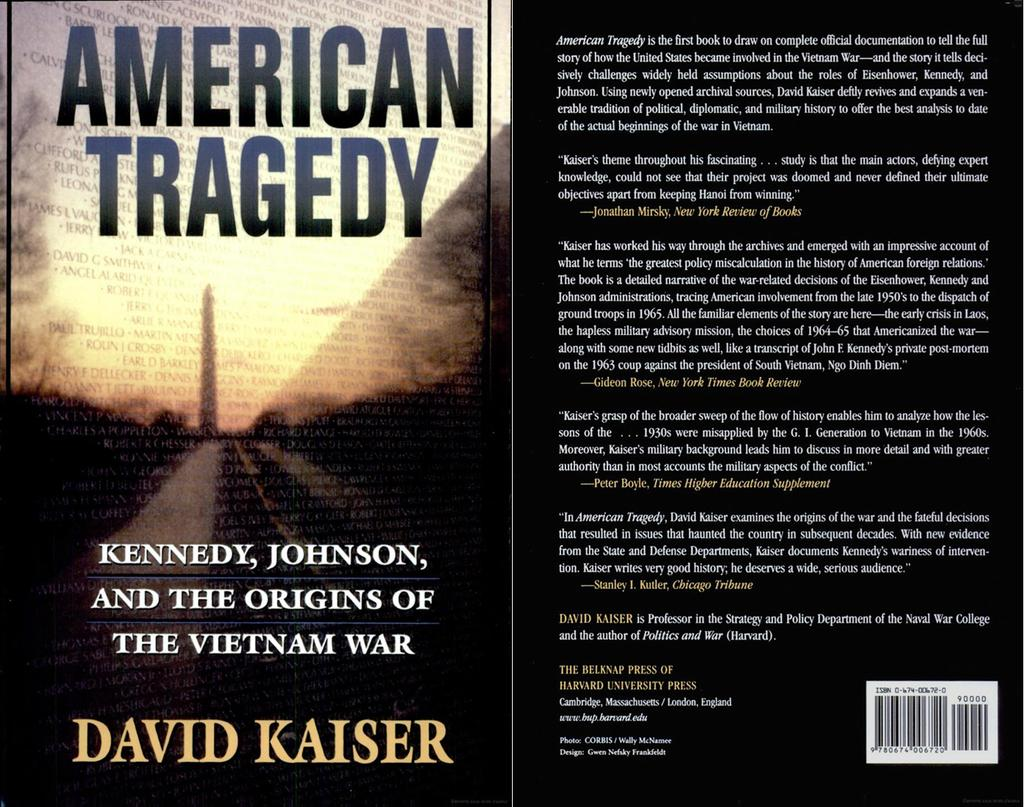<image>
Present a compact description of the photo's key features. A book cover called American Tragedy about Kennedy and Vietnam. 